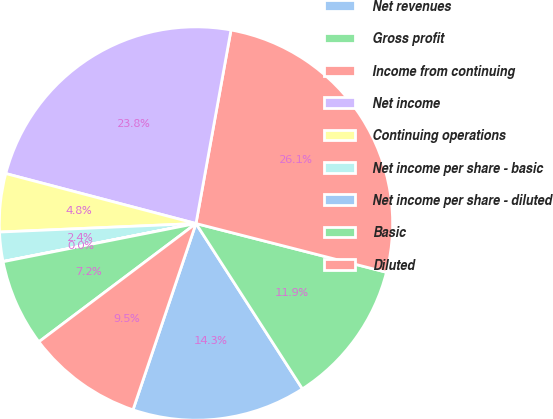Convert chart. <chart><loc_0><loc_0><loc_500><loc_500><pie_chart><fcel>Net revenues<fcel>Gross profit<fcel>Income from continuing<fcel>Net income<fcel>Continuing operations<fcel>Net income per share - basic<fcel>Net income per share - diluted<fcel>Basic<fcel>Diluted<nl><fcel>14.29%<fcel>11.91%<fcel>26.14%<fcel>23.76%<fcel>4.78%<fcel>2.4%<fcel>0.02%<fcel>7.16%<fcel>9.54%<nl></chart> 